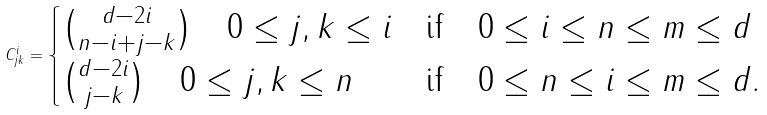<formula> <loc_0><loc_0><loc_500><loc_500>C ^ { i } _ { j k } = \begin{cases} \binom { d - 2 i } { n - i + j - k } \quad 0 \leq j , k \leq i & \text {if} \quad 0 \leq i \leq n \leq m \leq d \\ \binom { d - 2 i } { j - k } \quad 0 \leq j , k \leq n & \text {if} \quad 0 \leq n \leq i \leq m \leq d . \\ \end{cases}</formula> 